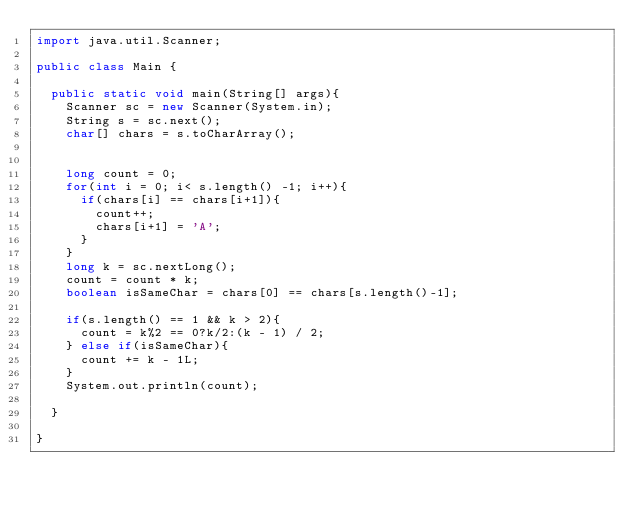<code> <loc_0><loc_0><loc_500><loc_500><_Java_>import java.util.Scanner;

public class Main {

  public static void main(String[] args){
    Scanner sc = new Scanner(System.in);
    String s = sc.next();
    char[] chars = s.toCharArray();


    long count = 0;
    for(int i = 0; i< s.length() -1; i++){
      if(chars[i] == chars[i+1]){
        count++;
        chars[i+1] = 'A';
      }
    }
    long k = sc.nextLong();
    count = count * k;
    boolean isSameChar = chars[0] == chars[s.length()-1];

    if(s.length() == 1 && k > 2){
      count = k%2 == 0?k/2:(k - 1) / 2;
    } else if(isSameChar){
      count += k - 1L;
    }
    System.out.println(count);

  }

}
</code> 